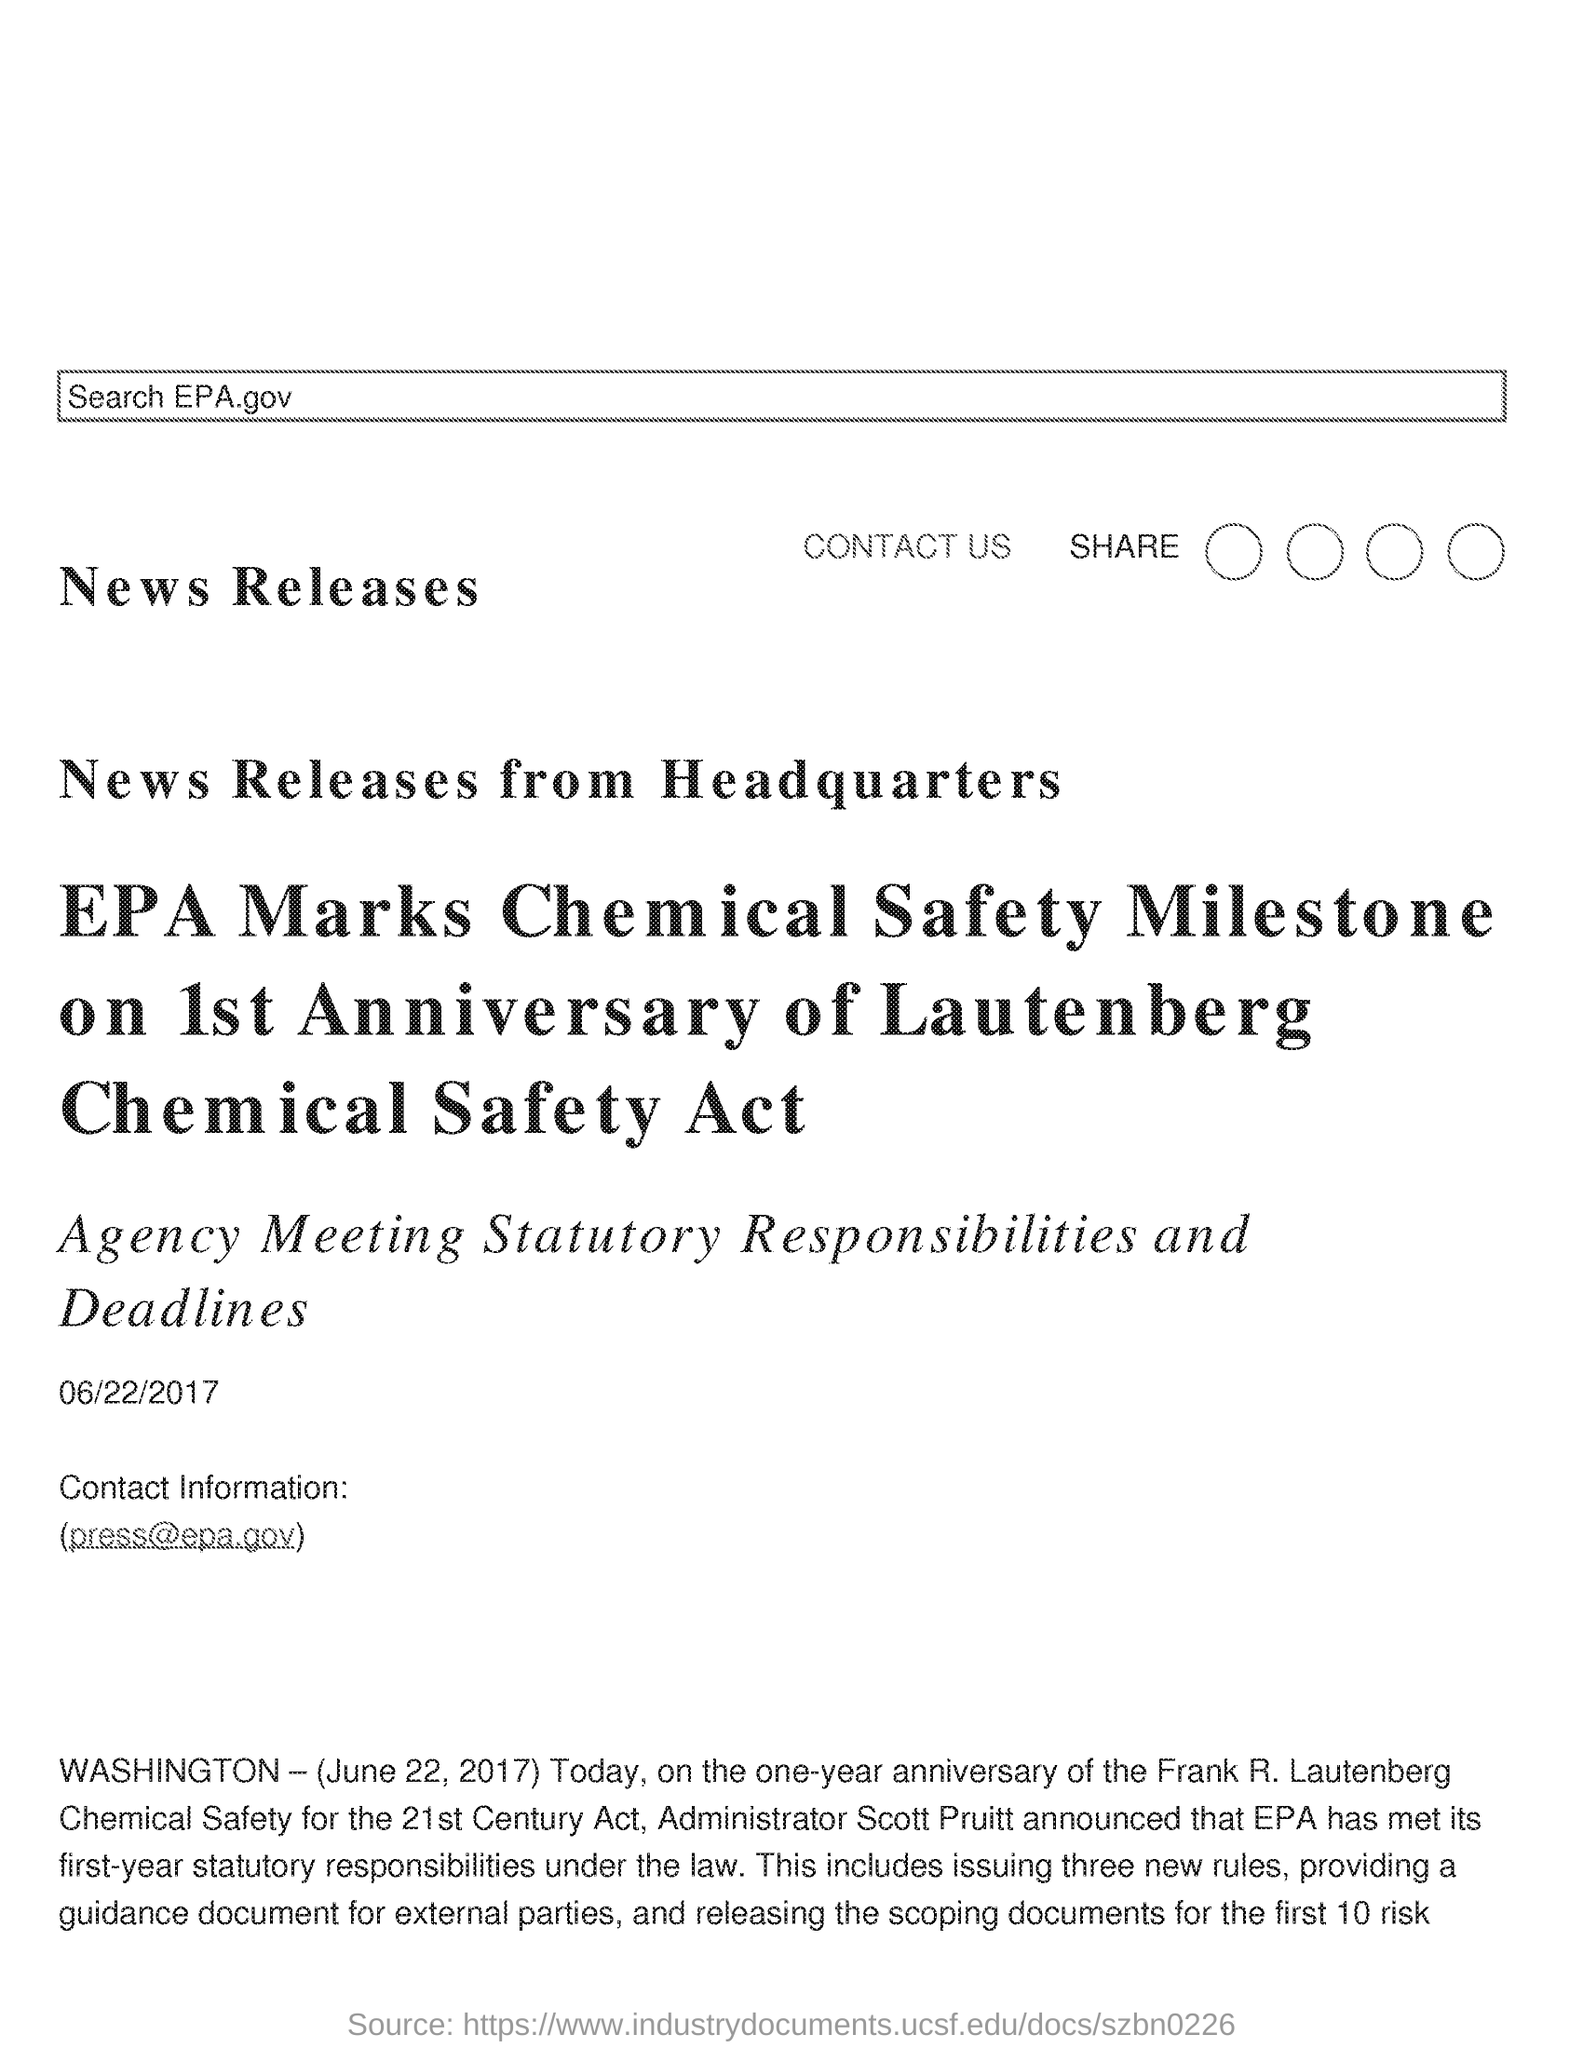What is the date mentioned in the document?
Provide a succinct answer. 06/22/2017. What is the contact information given in the document?
Offer a terse response. (press@epa.gov). 